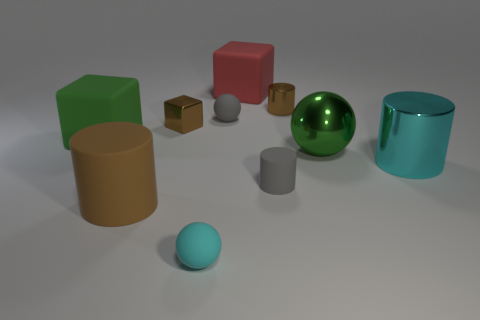There is a block that is the same color as the large rubber cylinder; what is its material?
Offer a very short reply. Metal. Is the color of the small metal cylinder the same as the large cylinder on the left side of the big green metal object?
Your answer should be very brief. Yes. What material is the brown object that is both behind the metal ball and in front of the tiny brown metallic cylinder?
Provide a succinct answer. Metal. There is a small shiny object that is the same shape as the big red rubber thing; what color is it?
Make the answer very short. Brown. What size is the green matte object?
Offer a very short reply. Large. What is the shape of the large thing that is both on the right side of the red matte block and to the left of the large metal cylinder?
Your response must be concise. Sphere. How many gray objects are either matte objects or tiny cylinders?
Your answer should be very brief. 2. There is a brown thing that is in front of the gray cylinder; is it the same size as the gray matte thing in front of the small gray ball?
Offer a terse response. No. How many things are either tiny cylinders or big red things?
Your answer should be compact. 3. Are there any big red things of the same shape as the green rubber object?
Keep it short and to the point. Yes. 